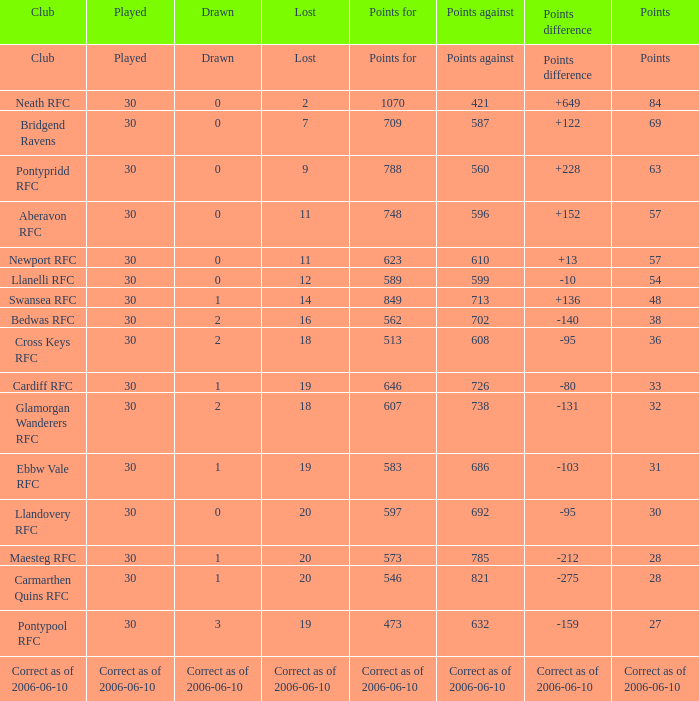What is Lost, when Drawn is "2", and when Points is "36"? 18.0. 